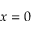Convert formula to latex. <formula><loc_0><loc_0><loc_500><loc_500>x = 0</formula> 